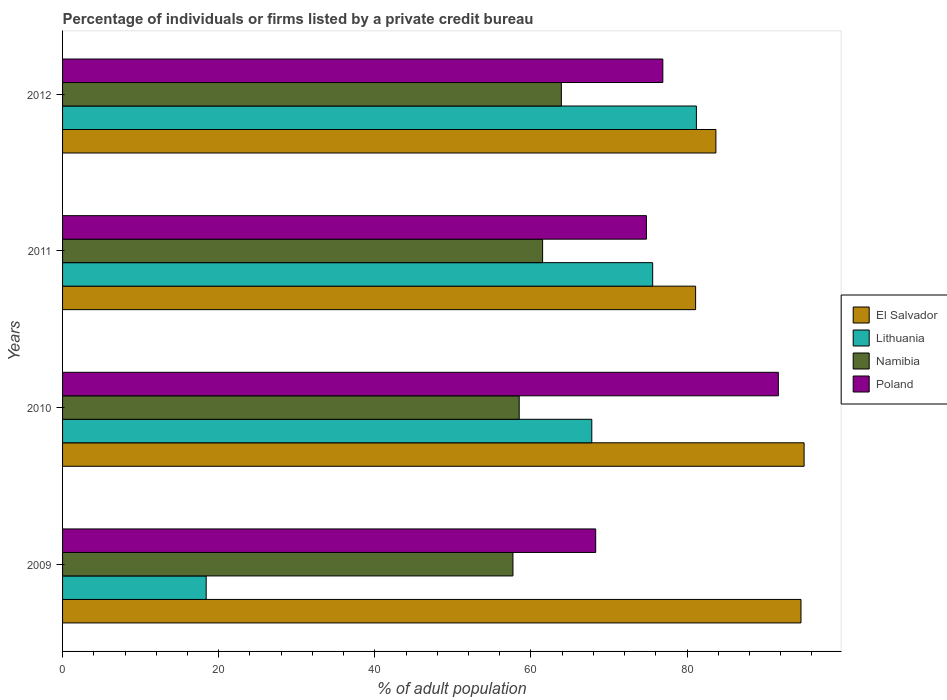How many groups of bars are there?
Offer a very short reply. 4. Are the number of bars per tick equal to the number of legend labels?
Your answer should be very brief. Yes. How many bars are there on the 4th tick from the top?
Your answer should be very brief. 4. How many bars are there on the 3rd tick from the bottom?
Provide a succinct answer. 4. What is the label of the 4th group of bars from the top?
Offer a terse response. 2009. In how many cases, is the number of bars for a given year not equal to the number of legend labels?
Offer a very short reply. 0. What is the percentage of population listed by a private credit bureau in Lithuania in 2012?
Make the answer very short. 81.2. Across all years, what is the maximum percentage of population listed by a private credit bureau in Namibia?
Your response must be concise. 63.9. Across all years, what is the minimum percentage of population listed by a private credit bureau in El Salvador?
Ensure brevity in your answer.  81.1. In which year was the percentage of population listed by a private credit bureau in El Salvador maximum?
Keep it short and to the point. 2010. In which year was the percentage of population listed by a private credit bureau in Poland minimum?
Ensure brevity in your answer.  2009. What is the total percentage of population listed by a private credit bureau in Poland in the graph?
Offer a very short reply. 311.7. What is the difference between the percentage of population listed by a private credit bureau in Poland in 2011 and that in 2012?
Provide a short and direct response. -2.1. What is the difference between the percentage of population listed by a private credit bureau in Namibia in 2009 and the percentage of population listed by a private credit bureau in El Salvador in 2011?
Offer a terse response. -23.4. What is the average percentage of population listed by a private credit bureau in Poland per year?
Give a very brief answer. 77.93. In the year 2012, what is the difference between the percentage of population listed by a private credit bureau in El Salvador and percentage of population listed by a private credit bureau in Namibia?
Ensure brevity in your answer.  19.8. What is the ratio of the percentage of population listed by a private credit bureau in Poland in 2009 to that in 2010?
Your answer should be very brief. 0.74. Is the percentage of population listed by a private credit bureau in Poland in 2009 less than that in 2012?
Provide a short and direct response. Yes. Is the difference between the percentage of population listed by a private credit bureau in El Salvador in 2009 and 2012 greater than the difference between the percentage of population listed by a private credit bureau in Namibia in 2009 and 2012?
Make the answer very short. Yes. What is the difference between the highest and the second highest percentage of population listed by a private credit bureau in Namibia?
Give a very brief answer. 2.4. What is the difference between the highest and the lowest percentage of population listed by a private credit bureau in Poland?
Offer a very short reply. 23.4. In how many years, is the percentage of population listed by a private credit bureau in Poland greater than the average percentage of population listed by a private credit bureau in Poland taken over all years?
Provide a succinct answer. 1. Is the sum of the percentage of population listed by a private credit bureau in Namibia in 2010 and 2011 greater than the maximum percentage of population listed by a private credit bureau in Poland across all years?
Ensure brevity in your answer.  Yes. Is it the case that in every year, the sum of the percentage of population listed by a private credit bureau in Lithuania and percentage of population listed by a private credit bureau in Namibia is greater than the sum of percentage of population listed by a private credit bureau in El Salvador and percentage of population listed by a private credit bureau in Poland?
Keep it short and to the point. No. What does the 4th bar from the bottom in 2009 represents?
Make the answer very short. Poland. How many years are there in the graph?
Give a very brief answer. 4. Does the graph contain grids?
Your response must be concise. No. How many legend labels are there?
Your response must be concise. 4. What is the title of the graph?
Provide a succinct answer. Percentage of individuals or firms listed by a private credit bureau. Does "Barbados" appear as one of the legend labels in the graph?
Keep it short and to the point. No. What is the label or title of the X-axis?
Keep it short and to the point. % of adult population. What is the % of adult population in El Salvador in 2009?
Provide a succinct answer. 94.6. What is the % of adult population of Namibia in 2009?
Offer a terse response. 57.7. What is the % of adult population in Poland in 2009?
Offer a terse response. 68.3. What is the % of adult population of El Salvador in 2010?
Make the answer very short. 95. What is the % of adult population of Lithuania in 2010?
Make the answer very short. 67.8. What is the % of adult population of Namibia in 2010?
Your answer should be very brief. 58.5. What is the % of adult population of Poland in 2010?
Provide a short and direct response. 91.7. What is the % of adult population of El Salvador in 2011?
Provide a short and direct response. 81.1. What is the % of adult population of Lithuania in 2011?
Provide a succinct answer. 75.6. What is the % of adult population in Namibia in 2011?
Your response must be concise. 61.5. What is the % of adult population of Poland in 2011?
Offer a very short reply. 74.8. What is the % of adult population in El Salvador in 2012?
Offer a very short reply. 83.7. What is the % of adult population of Lithuania in 2012?
Your response must be concise. 81.2. What is the % of adult population in Namibia in 2012?
Provide a short and direct response. 63.9. What is the % of adult population in Poland in 2012?
Your answer should be compact. 76.9. Across all years, what is the maximum % of adult population in Lithuania?
Ensure brevity in your answer.  81.2. Across all years, what is the maximum % of adult population in Namibia?
Give a very brief answer. 63.9. Across all years, what is the maximum % of adult population in Poland?
Ensure brevity in your answer.  91.7. Across all years, what is the minimum % of adult population in El Salvador?
Keep it short and to the point. 81.1. Across all years, what is the minimum % of adult population of Lithuania?
Ensure brevity in your answer.  18.4. Across all years, what is the minimum % of adult population of Namibia?
Offer a terse response. 57.7. Across all years, what is the minimum % of adult population of Poland?
Your answer should be very brief. 68.3. What is the total % of adult population of El Salvador in the graph?
Make the answer very short. 354.4. What is the total % of adult population in Lithuania in the graph?
Your answer should be compact. 243. What is the total % of adult population of Namibia in the graph?
Your answer should be very brief. 241.6. What is the total % of adult population in Poland in the graph?
Make the answer very short. 311.7. What is the difference between the % of adult population in Lithuania in 2009 and that in 2010?
Your answer should be very brief. -49.4. What is the difference between the % of adult population of Poland in 2009 and that in 2010?
Provide a succinct answer. -23.4. What is the difference between the % of adult population in Lithuania in 2009 and that in 2011?
Your response must be concise. -57.2. What is the difference between the % of adult population of Namibia in 2009 and that in 2011?
Offer a very short reply. -3.8. What is the difference between the % of adult population of Lithuania in 2009 and that in 2012?
Give a very brief answer. -62.8. What is the difference between the % of adult population in Namibia in 2009 and that in 2012?
Offer a terse response. -6.2. What is the difference between the % of adult population in Poland in 2009 and that in 2012?
Ensure brevity in your answer.  -8.6. What is the difference between the % of adult population in Lithuania in 2010 and that in 2011?
Your response must be concise. -7.8. What is the difference between the % of adult population of Poland in 2010 and that in 2011?
Make the answer very short. 16.9. What is the difference between the % of adult population in El Salvador in 2010 and that in 2012?
Give a very brief answer. 11.3. What is the difference between the % of adult population of Lithuania in 2010 and that in 2012?
Keep it short and to the point. -13.4. What is the difference between the % of adult population of Poland in 2010 and that in 2012?
Provide a short and direct response. 14.8. What is the difference between the % of adult population in Lithuania in 2011 and that in 2012?
Your response must be concise. -5.6. What is the difference between the % of adult population of Namibia in 2011 and that in 2012?
Give a very brief answer. -2.4. What is the difference between the % of adult population in El Salvador in 2009 and the % of adult population in Lithuania in 2010?
Offer a terse response. 26.8. What is the difference between the % of adult population in El Salvador in 2009 and the % of adult population in Namibia in 2010?
Give a very brief answer. 36.1. What is the difference between the % of adult population of Lithuania in 2009 and the % of adult population of Namibia in 2010?
Offer a very short reply. -40.1. What is the difference between the % of adult population of Lithuania in 2009 and the % of adult population of Poland in 2010?
Your answer should be very brief. -73.3. What is the difference between the % of adult population in Namibia in 2009 and the % of adult population in Poland in 2010?
Your response must be concise. -34. What is the difference between the % of adult population in El Salvador in 2009 and the % of adult population in Lithuania in 2011?
Make the answer very short. 19. What is the difference between the % of adult population in El Salvador in 2009 and the % of adult population in Namibia in 2011?
Give a very brief answer. 33.1. What is the difference between the % of adult population in El Salvador in 2009 and the % of adult population in Poland in 2011?
Offer a very short reply. 19.8. What is the difference between the % of adult population of Lithuania in 2009 and the % of adult population of Namibia in 2011?
Offer a terse response. -43.1. What is the difference between the % of adult population of Lithuania in 2009 and the % of adult population of Poland in 2011?
Your answer should be very brief. -56.4. What is the difference between the % of adult population of Namibia in 2009 and the % of adult population of Poland in 2011?
Make the answer very short. -17.1. What is the difference between the % of adult population of El Salvador in 2009 and the % of adult population of Lithuania in 2012?
Offer a very short reply. 13.4. What is the difference between the % of adult population in El Salvador in 2009 and the % of adult population in Namibia in 2012?
Give a very brief answer. 30.7. What is the difference between the % of adult population of Lithuania in 2009 and the % of adult population of Namibia in 2012?
Make the answer very short. -45.5. What is the difference between the % of adult population in Lithuania in 2009 and the % of adult population in Poland in 2012?
Keep it short and to the point. -58.5. What is the difference between the % of adult population of Namibia in 2009 and the % of adult population of Poland in 2012?
Provide a short and direct response. -19.2. What is the difference between the % of adult population of El Salvador in 2010 and the % of adult population of Namibia in 2011?
Keep it short and to the point. 33.5. What is the difference between the % of adult population in El Salvador in 2010 and the % of adult population in Poland in 2011?
Your answer should be very brief. 20.2. What is the difference between the % of adult population in Lithuania in 2010 and the % of adult population in Poland in 2011?
Keep it short and to the point. -7. What is the difference between the % of adult population in Namibia in 2010 and the % of adult population in Poland in 2011?
Offer a very short reply. -16.3. What is the difference between the % of adult population of El Salvador in 2010 and the % of adult population of Lithuania in 2012?
Make the answer very short. 13.8. What is the difference between the % of adult population of El Salvador in 2010 and the % of adult population of Namibia in 2012?
Provide a short and direct response. 31.1. What is the difference between the % of adult population in El Salvador in 2010 and the % of adult population in Poland in 2012?
Your answer should be compact. 18.1. What is the difference between the % of adult population in Lithuania in 2010 and the % of adult population in Namibia in 2012?
Keep it short and to the point. 3.9. What is the difference between the % of adult population of Namibia in 2010 and the % of adult population of Poland in 2012?
Your answer should be compact. -18.4. What is the difference between the % of adult population in El Salvador in 2011 and the % of adult population in Lithuania in 2012?
Your answer should be very brief. -0.1. What is the difference between the % of adult population of El Salvador in 2011 and the % of adult population of Namibia in 2012?
Offer a terse response. 17.2. What is the difference between the % of adult population of Namibia in 2011 and the % of adult population of Poland in 2012?
Provide a short and direct response. -15.4. What is the average % of adult population of El Salvador per year?
Your response must be concise. 88.6. What is the average % of adult population in Lithuania per year?
Your answer should be compact. 60.75. What is the average % of adult population of Namibia per year?
Make the answer very short. 60.4. What is the average % of adult population of Poland per year?
Ensure brevity in your answer.  77.92. In the year 2009, what is the difference between the % of adult population of El Salvador and % of adult population of Lithuania?
Keep it short and to the point. 76.2. In the year 2009, what is the difference between the % of adult population in El Salvador and % of adult population in Namibia?
Offer a very short reply. 36.9. In the year 2009, what is the difference between the % of adult population of El Salvador and % of adult population of Poland?
Your answer should be compact. 26.3. In the year 2009, what is the difference between the % of adult population of Lithuania and % of adult population of Namibia?
Your answer should be very brief. -39.3. In the year 2009, what is the difference between the % of adult population in Lithuania and % of adult population in Poland?
Your response must be concise. -49.9. In the year 2010, what is the difference between the % of adult population of El Salvador and % of adult population of Lithuania?
Provide a succinct answer. 27.2. In the year 2010, what is the difference between the % of adult population of El Salvador and % of adult population of Namibia?
Give a very brief answer. 36.5. In the year 2010, what is the difference between the % of adult population in Lithuania and % of adult population in Namibia?
Your answer should be very brief. 9.3. In the year 2010, what is the difference between the % of adult population of Lithuania and % of adult population of Poland?
Ensure brevity in your answer.  -23.9. In the year 2010, what is the difference between the % of adult population of Namibia and % of adult population of Poland?
Give a very brief answer. -33.2. In the year 2011, what is the difference between the % of adult population in El Salvador and % of adult population in Namibia?
Keep it short and to the point. 19.6. In the year 2011, what is the difference between the % of adult population of Lithuania and % of adult population of Namibia?
Provide a succinct answer. 14.1. In the year 2011, what is the difference between the % of adult population of Lithuania and % of adult population of Poland?
Offer a terse response. 0.8. In the year 2012, what is the difference between the % of adult population of El Salvador and % of adult population of Namibia?
Your response must be concise. 19.8. In the year 2012, what is the difference between the % of adult population of El Salvador and % of adult population of Poland?
Your answer should be very brief. 6.8. In the year 2012, what is the difference between the % of adult population in Namibia and % of adult population in Poland?
Offer a very short reply. -13. What is the ratio of the % of adult population in El Salvador in 2009 to that in 2010?
Give a very brief answer. 1. What is the ratio of the % of adult population in Lithuania in 2009 to that in 2010?
Ensure brevity in your answer.  0.27. What is the ratio of the % of adult population in Namibia in 2009 to that in 2010?
Ensure brevity in your answer.  0.99. What is the ratio of the % of adult population in Poland in 2009 to that in 2010?
Make the answer very short. 0.74. What is the ratio of the % of adult population of El Salvador in 2009 to that in 2011?
Provide a short and direct response. 1.17. What is the ratio of the % of adult population in Lithuania in 2009 to that in 2011?
Your response must be concise. 0.24. What is the ratio of the % of adult population in Namibia in 2009 to that in 2011?
Keep it short and to the point. 0.94. What is the ratio of the % of adult population of Poland in 2009 to that in 2011?
Your answer should be compact. 0.91. What is the ratio of the % of adult population of El Salvador in 2009 to that in 2012?
Your response must be concise. 1.13. What is the ratio of the % of adult population of Lithuania in 2009 to that in 2012?
Offer a terse response. 0.23. What is the ratio of the % of adult population in Namibia in 2009 to that in 2012?
Make the answer very short. 0.9. What is the ratio of the % of adult population in Poland in 2009 to that in 2012?
Offer a very short reply. 0.89. What is the ratio of the % of adult population of El Salvador in 2010 to that in 2011?
Your answer should be compact. 1.17. What is the ratio of the % of adult population of Lithuania in 2010 to that in 2011?
Give a very brief answer. 0.9. What is the ratio of the % of adult population in Namibia in 2010 to that in 2011?
Your response must be concise. 0.95. What is the ratio of the % of adult population in Poland in 2010 to that in 2011?
Provide a short and direct response. 1.23. What is the ratio of the % of adult population in El Salvador in 2010 to that in 2012?
Provide a short and direct response. 1.14. What is the ratio of the % of adult population of Lithuania in 2010 to that in 2012?
Ensure brevity in your answer.  0.83. What is the ratio of the % of adult population of Namibia in 2010 to that in 2012?
Your answer should be very brief. 0.92. What is the ratio of the % of adult population in Poland in 2010 to that in 2012?
Your response must be concise. 1.19. What is the ratio of the % of adult population of El Salvador in 2011 to that in 2012?
Offer a terse response. 0.97. What is the ratio of the % of adult population of Namibia in 2011 to that in 2012?
Your response must be concise. 0.96. What is the ratio of the % of adult population in Poland in 2011 to that in 2012?
Make the answer very short. 0.97. What is the difference between the highest and the second highest % of adult population of El Salvador?
Ensure brevity in your answer.  0.4. What is the difference between the highest and the second highest % of adult population of Lithuania?
Your answer should be very brief. 5.6. What is the difference between the highest and the second highest % of adult population in Namibia?
Give a very brief answer. 2.4. What is the difference between the highest and the lowest % of adult population in Lithuania?
Make the answer very short. 62.8. What is the difference between the highest and the lowest % of adult population of Poland?
Give a very brief answer. 23.4. 